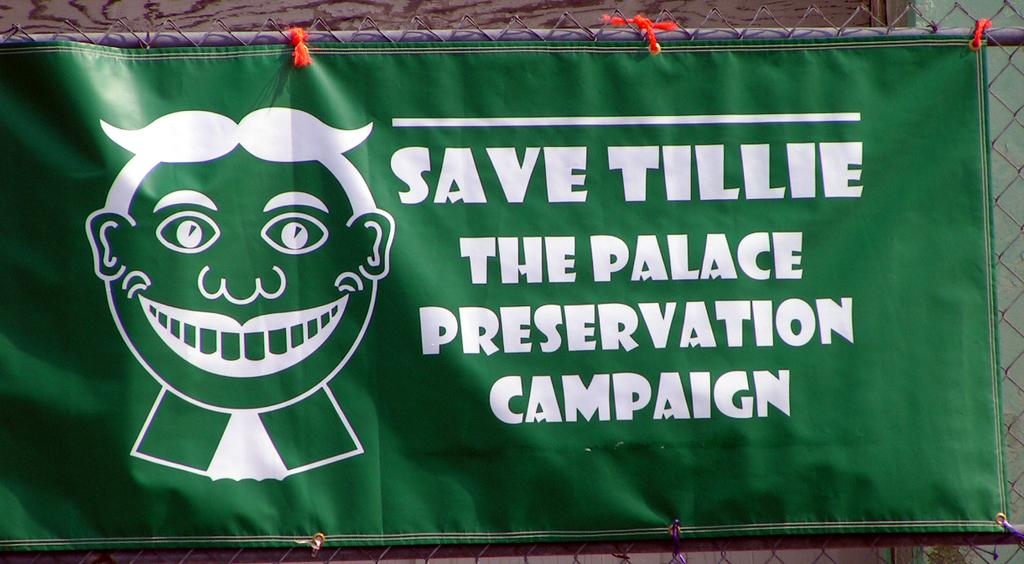<image>
Share a concise interpretation of the image provided. A green banner asking that Tillie be saved. 